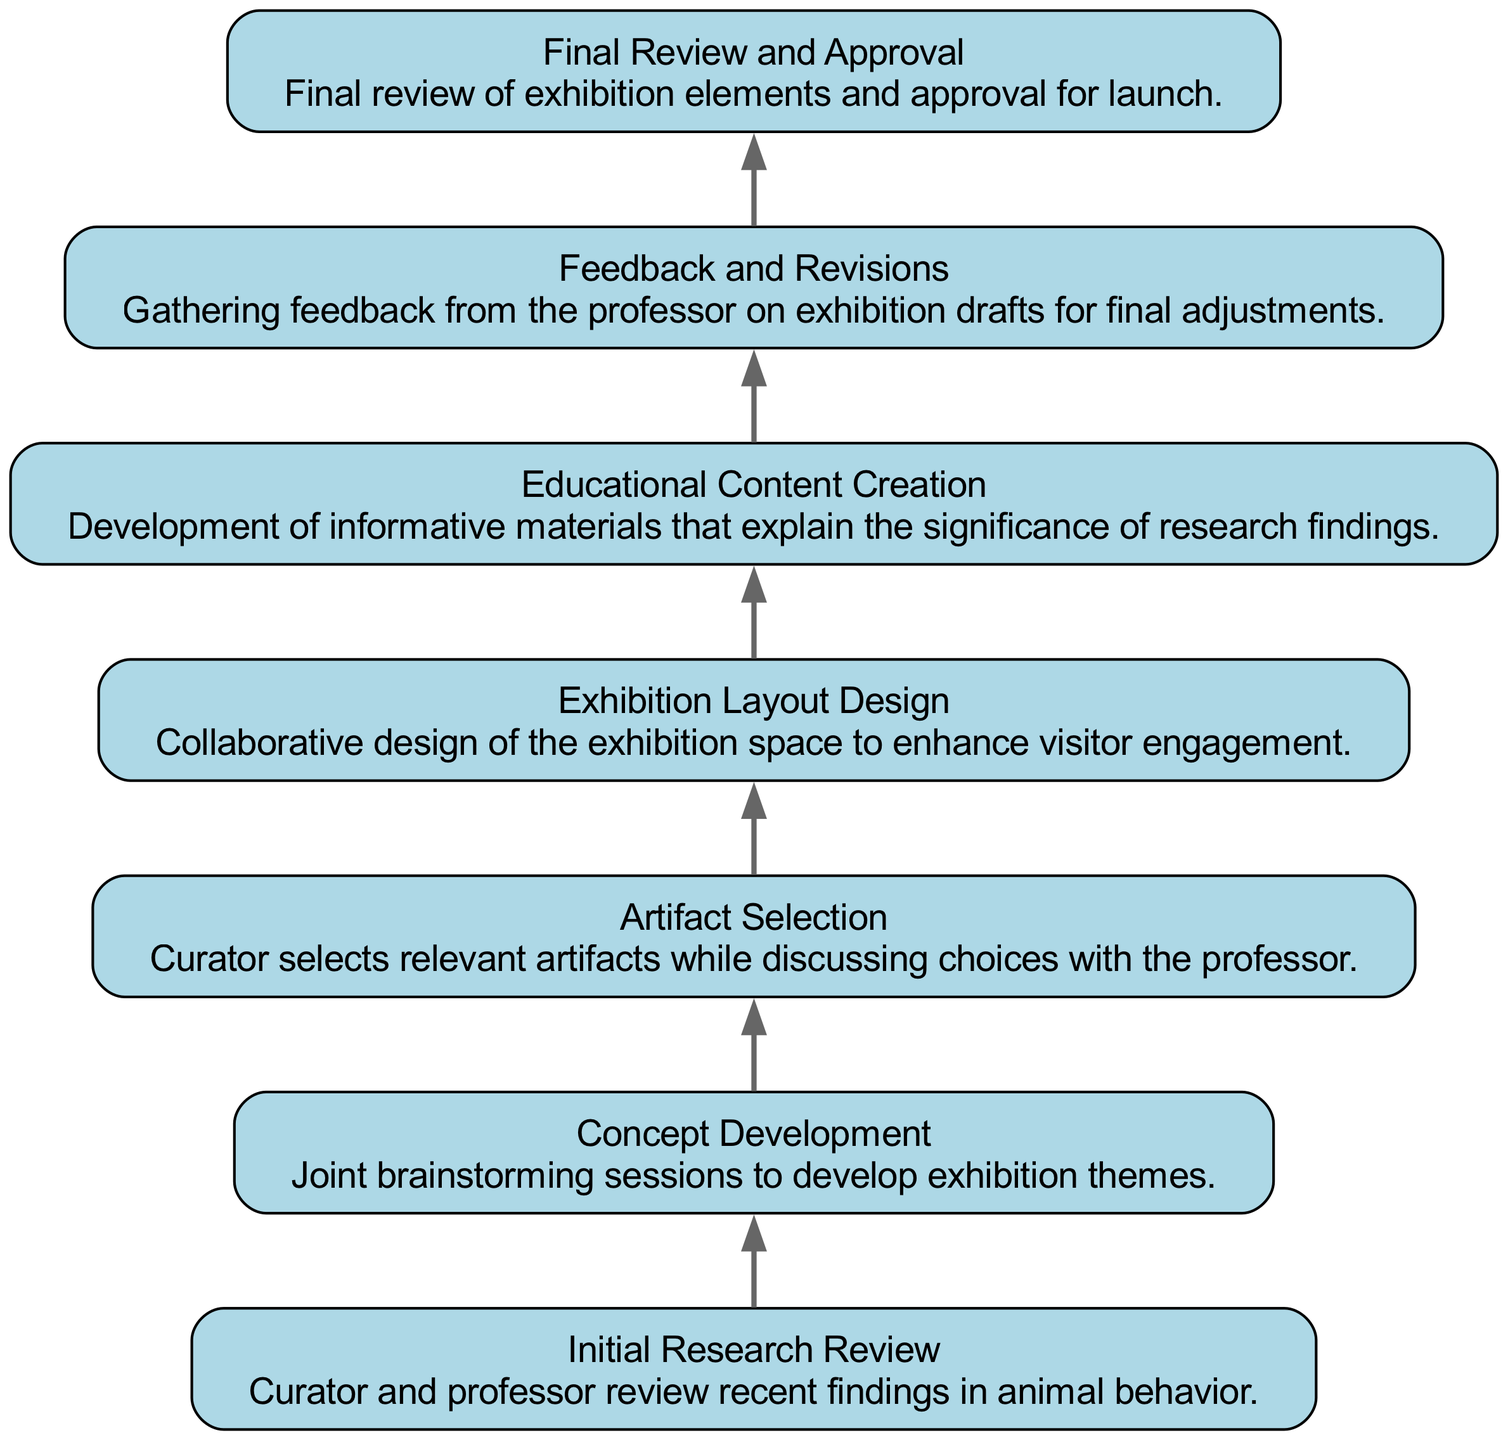What is the first step in the collaboration workflow? The first step listed in the diagram is "Initial Research Review," which is where the curator and professor review recent findings in animal behavior.
Answer: Initial Research Review How many nodes are there in the diagram? By counting each distinct step from "Initial Research Review" to "Final Review and Approval," a total of 7 nodes are present in the diagram.
Answer: 7 What is the final step in the process? The last node in the flow chart is "Final Review and Approval," indicating the final step before launching the exhibition.
Answer: Final Review and Approval Which step involves artifact selection? The node titled "Artifact Selection" directly mentions the curator selecting relevant artifacts while discussing choices with the professor, making it the relevant step.
Answer: Artifact Selection What step comes directly after Feedback and Revisions? The node "Final Review and Approval" follows the "Feedback and Revisions," creating a direct sequence from gathering feedback to final approval.
Answer: Final Review and Approval What is the main focus of Educational Content Creation? "Educational Content Creation" is primarily focused on developing informative materials that explain the significance of research findings, highlighting its role in conveying information.
Answer: Informative materials Which step emphasizes the collaborative design aspect? The step labeled "Exhibition Layout Design" specifies that it is a collaborative effort to design the exhibition space, emphasizing joint participation in this task.
Answer: Collaborative design How does the flow of the diagram progress from step to step? The flow appears to indicate a sequential progression from one step to the next, starting from the initial research review and culminating in the final review and approval. Each step builds on the previous one.
Answer: Sequential progression 